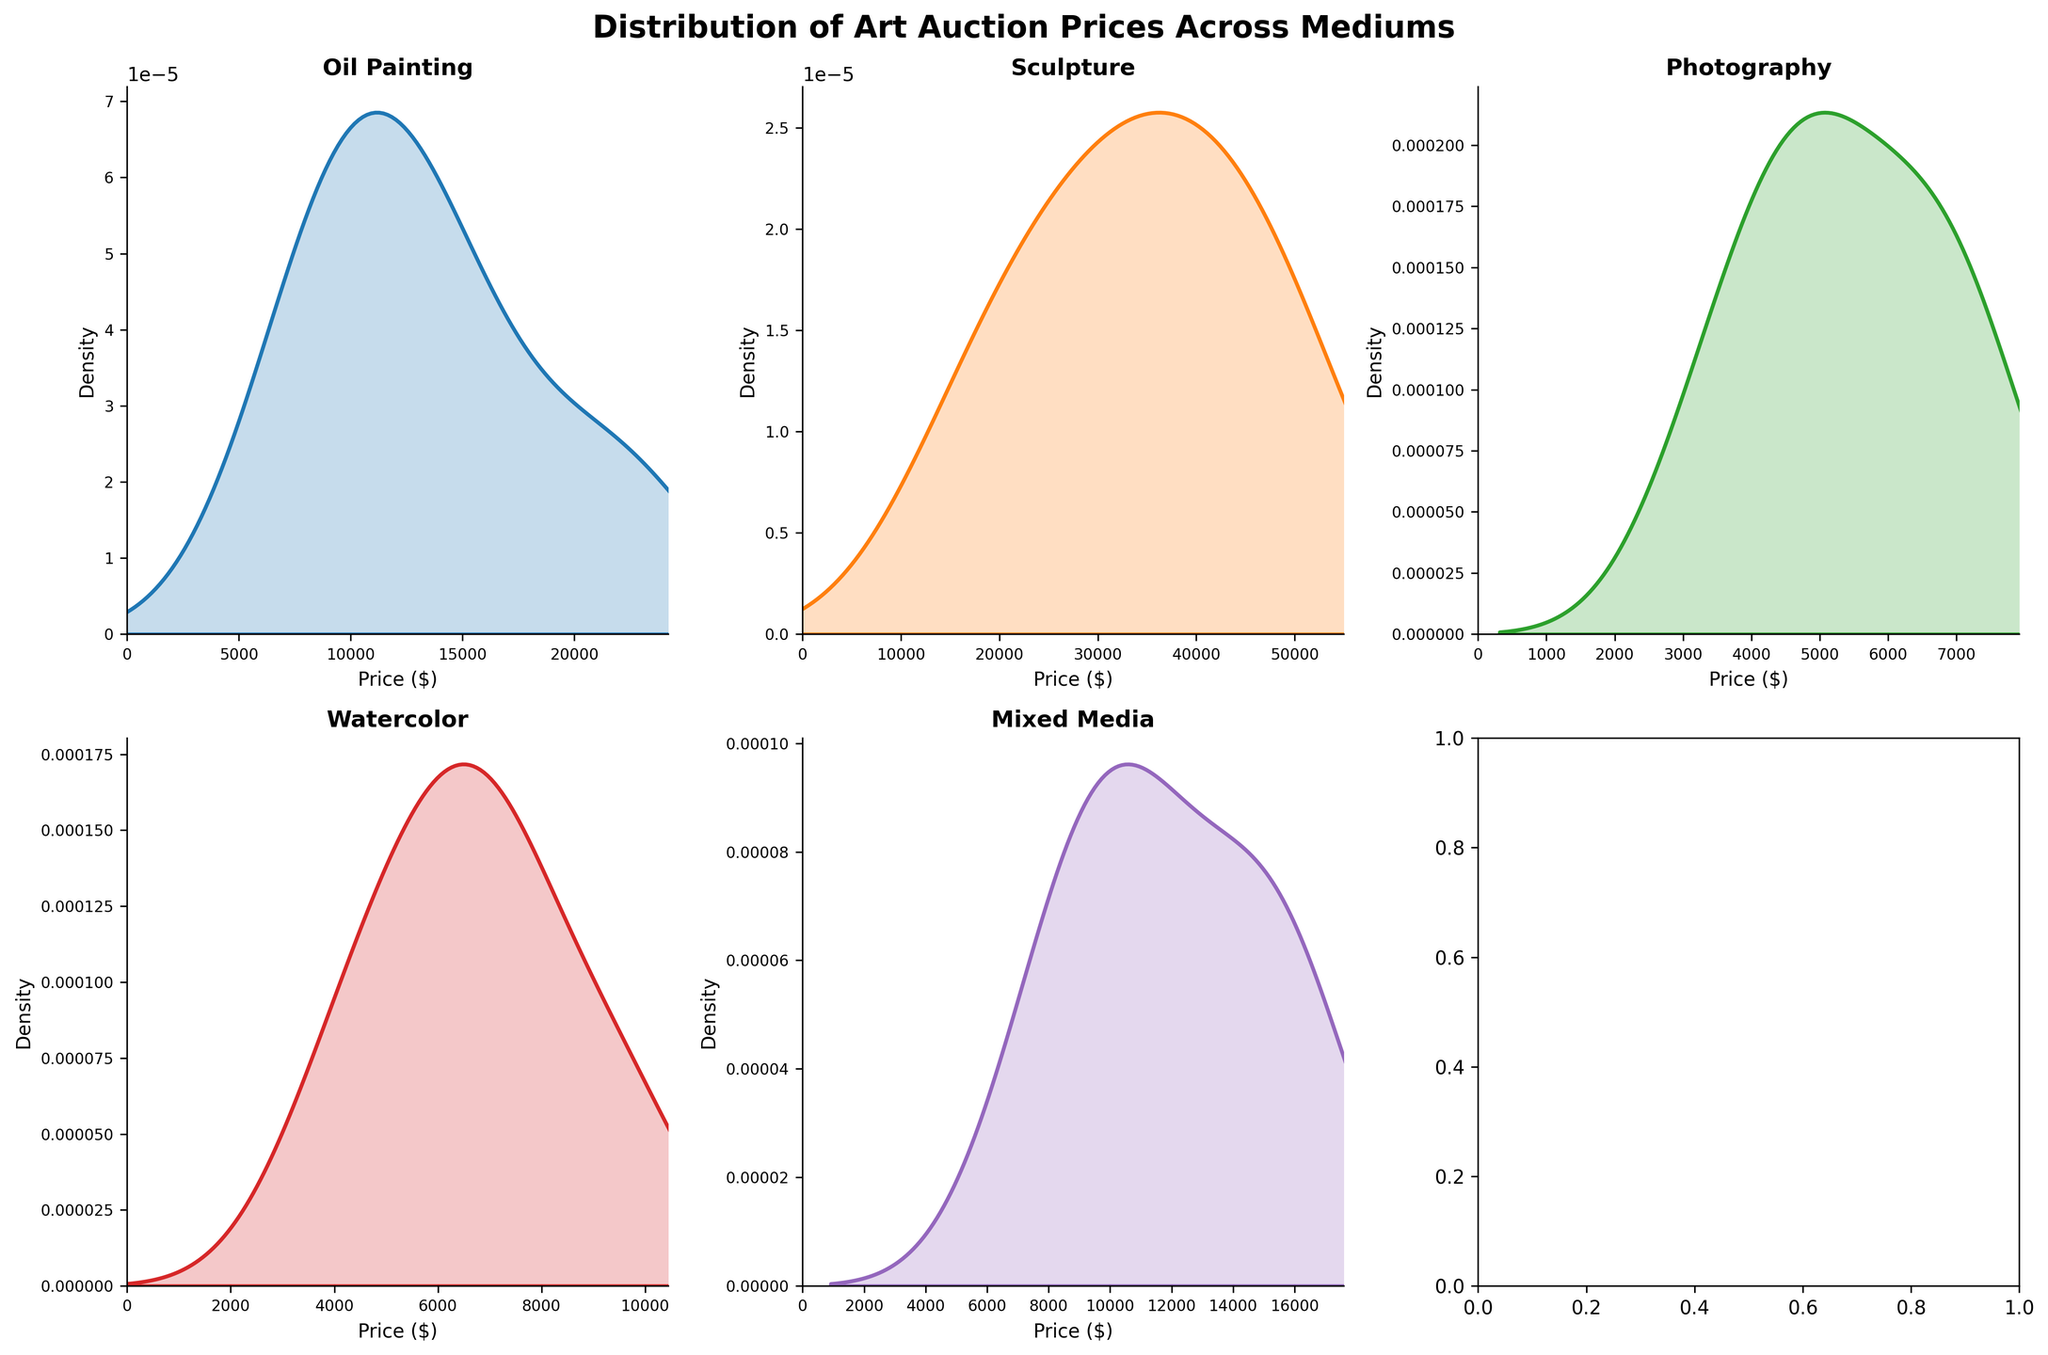What mediums are compared in the figure? The figure includes five subplots, each dedicated to a different artistic medium. The titles of the subplots indicate that the mediums compared are Oil Painting, Sculpture, Photography, Watercolor, and Mixed Media.
Answer: Oil Painting, Sculpture, Photography, Watercolor, Mixed Media Which medium shows the highest peak in its density plot? By observing the figure, the peak of the density plot for Sculpture reaches higher than the rest, indicating that it has the highest density at a particular price range compared to the others.
Answer: Sculpture What is the price range for Oil Paintings in the density plot? The x-axis for the Oil Painting subplot gives the price range, which starts from 0 and goes up to slightly above 22,000 dollars, considering the maximum value is set to approximately 1.1 times the maximum price observed in the data.
Answer: 0 to slightly above 22,000 dollars Which medium has the widest spread in auction prices? The density plot of Sculpture spans the widest range of prices among all mediums, indicating the highest variability in auction prices. The price range extends roughly from 0 to just over 50,000 dollars.
Answer: Sculpture In terms of density, how does the peak density of Photography compare to Mixed Media? By visually comparing the peaks of the density plots for Photography and Mixed Media, it can be observed that the density peak for Mixed Media is higher than that of Photography, indicating that the highest concentration of prices for Mixed Media is greater than for Photography.
Answer: The peak density of Mixed Media is higher What can you infer about the distribution of prices for Watercolor as compared to Oil Painting? Comparing the density plots of Watercolor to Oil Painting, Watercolor shows a slightly more spread-out distribution with no pronounced peak, whereas Oil Painting has a relatively more peaked distribution centered around 10,000 to 15,000 dollars.
Answer: Watercolor is more spread out, Oil Painting is more peaked Is the distribution of prices for Mixed Media skewed or symmetric? By examining the shape of the density plot for Mixed Media, it appears that the distribution is somewhat symmetric, with a peak around the center and tails roughly equal on both sides.
Answer: Symmetric Which artistic medium has the least variability in auction prices according to the density plots? The density plot for Photography appears to be the narrowest compared to the other mediums, indicating that Photography has the least variability in auction prices with prices centered between roughly 3,000 to 7,000 dollars.
Answer: Photography How do the price ranges for Oil Painting and Watercolor compare? The x-axis for both subplots shows that the price range for Oil Painting (up to approximately 22,000 dollars) is broader than that for Watercolor (up to approximately 9,500 dollars). This implies that Oil Paintings have a higher maximum auction price than Watercolors.
Answer: Oil Painting's price range is broader than Watercolor 